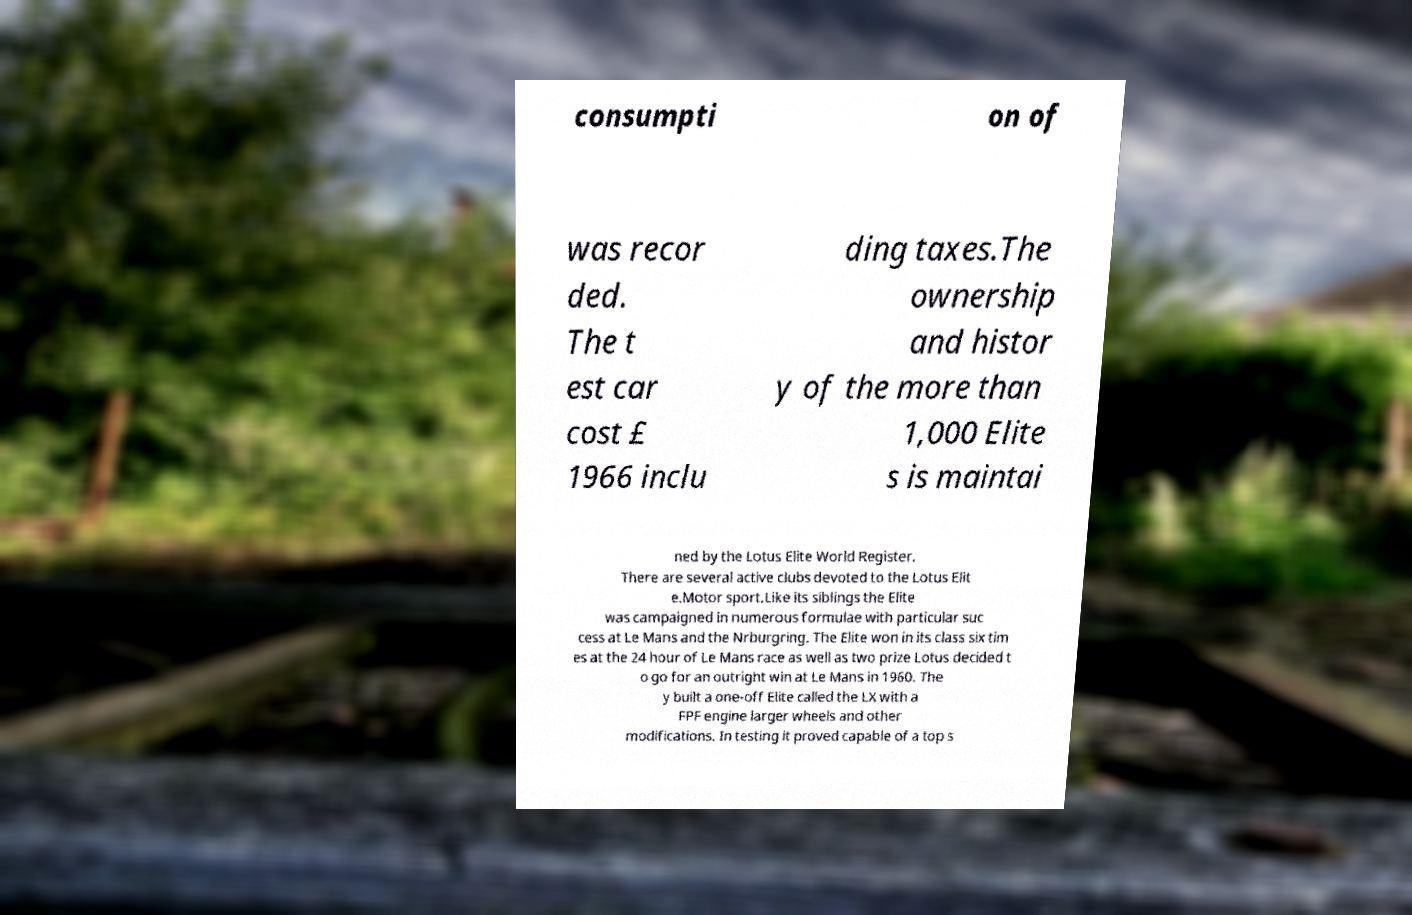What messages or text are displayed in this image? I need them in a readable, typed format. consumpti on of was recor ded. The t est car cost £ 1966 inclu ding taxes.The ownership and histor y of the more than 1,000 Elite s is maintai ned by the Lotus Elite World Register. There are several active clubs devoted to the Lotus Elit e.Motor sport.Like its siblings the Elite was campaigned in numerous formulae with particular suc cess at Le Mans and the Nrburgring. The Elite won in its class six tim es at the 24 hour of Le Mans race as well as two prize Lotus decided t o go for an outright win at Le Mans in 1960. The y built a one-off Elite called the LX with a FPF engine larger wheels and other modifications. In testing it proved capable of a top s 